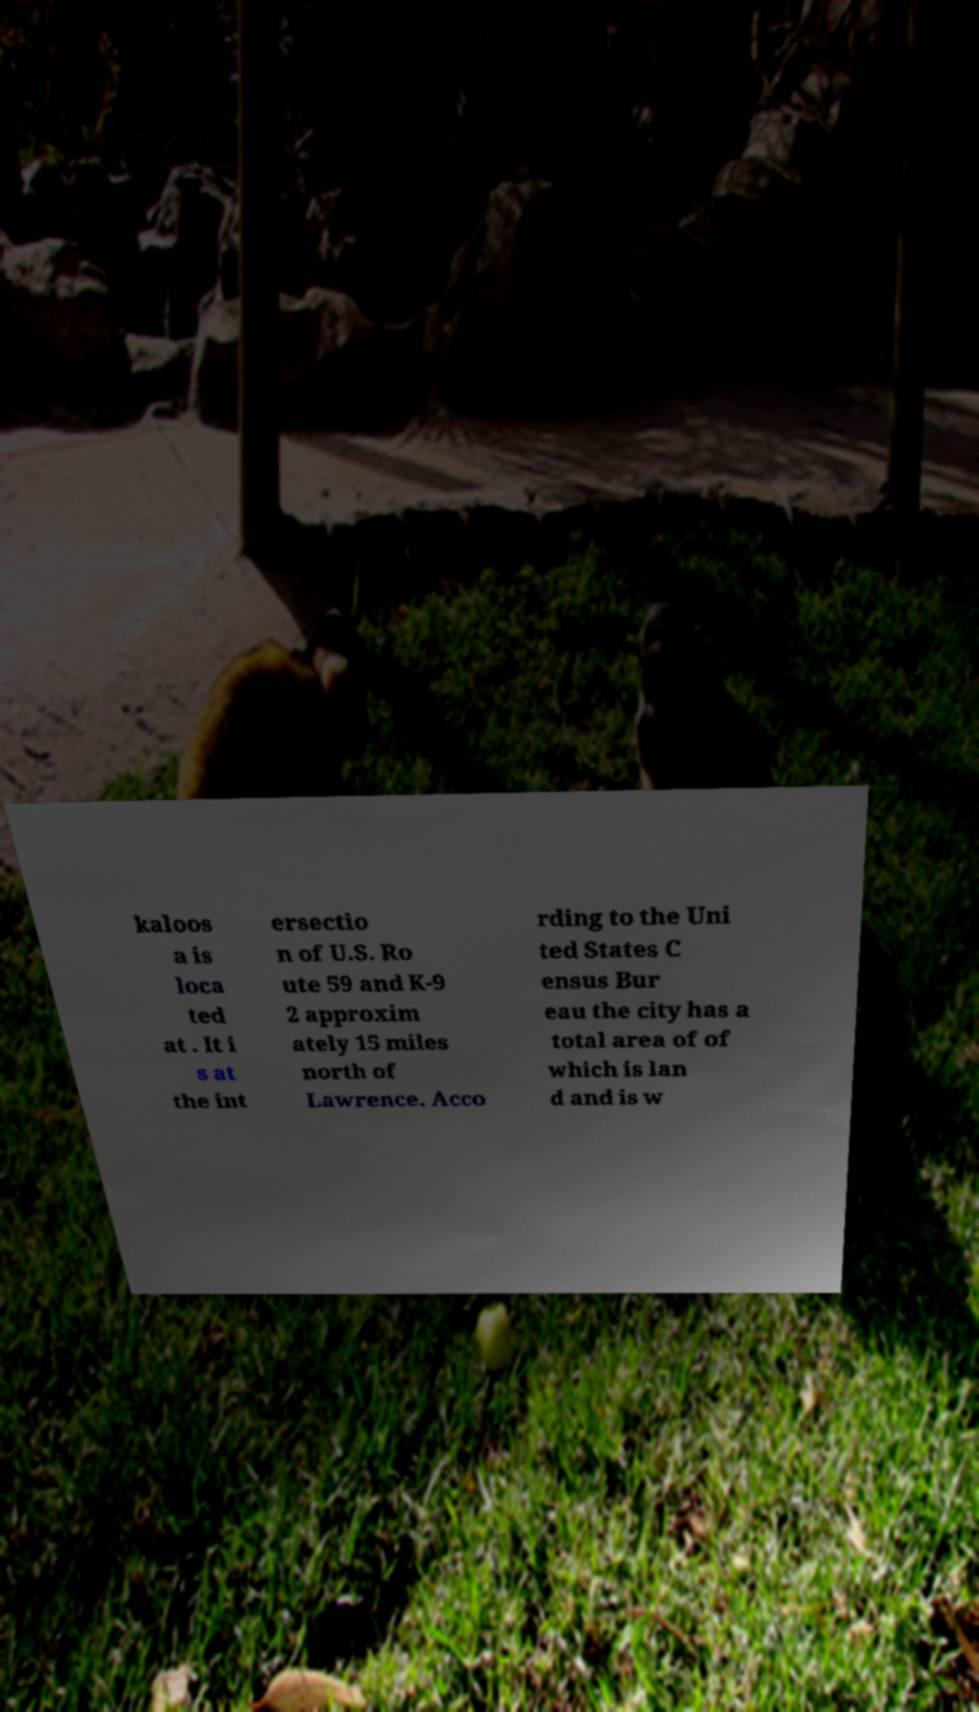Could you extract and type out the text from this image? kaloos a is loca ted at . It i s at the int ersectio n of U.S. Ro ute 59 and K-9 2 approxim ately 15 miles north of Lawrence. Acco rding to the Uni ted States C ensus Bur eau the city has a total area of of which is lan d and is w 